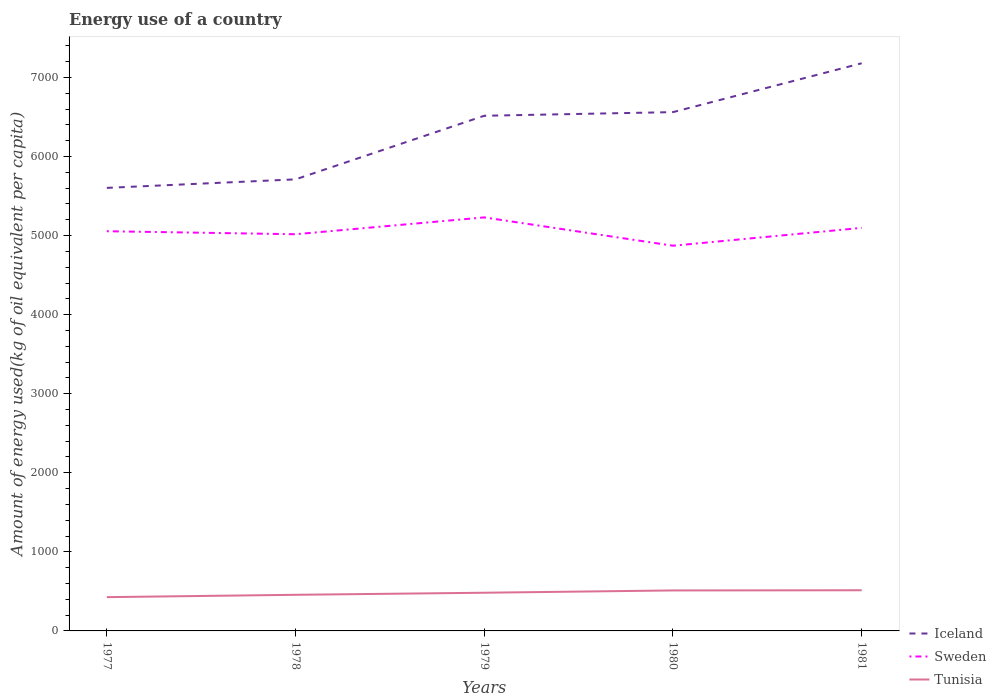Does the line corresponding to Iceland intersect with the line corresponding to Sweden?
Provide a succinct answer. No. Across all years, what is the maximum amount of energy used in in Sweden?
Your answer should be very brief. 4871.53. In which year was the amount of energy used in in Tunisia maximum?
Your response must be concise. 1977. What is the total amount of energy used in in Sweden in the graph?
Provide a short and direct response. 145.21. What is the difference between the highest and the second highest amount of energy used in in Iceland?
Your answer should be compact. 1576. Is the amount of energy used in in Tunisia strictly greater than the amount of energy used in in Sweden over the years?
Your response must be concise. Yes. How many years are there in the graph?
Your answer should be compact. 5. What is the difference between two consecutive major ticks on the Y-axis?
Offer a terse response. 1000. Are the values on the major ticks of Y-axis written in scientific E-notation?
Offer a terse response. No. Does the graph contain any zero values?
Make the answer very short. No. Does the graph contain grids?
Your answer should be compact. No. What is the title of the graph?
Offer a terse response. Energy use of a country. What is the label or title of the Y-axis?
Give a very brief answer. Amount of energy used(kg of oil equivalent per capita). What is the Amount of energy used(kg of oil equivalent per capita) in Iceland in 1977?
Offer a terse response. 5602.87. What is the Amount of energy used(kg of oil equivalent per capita) in Sweden in 1977?
Make the answer very short. 5054.83. What is the Amount of energy used(kg of oil equivalent per capita) in Tunisia in 1977?
Provide a succinct answer. 427.3. What is the Amount of energy used(kg of oil equivalent per capita) of Iceland in 1978?
Provide a succinct answer. 5710.71. What is the Amount of energy used(kg of oil equivalent per capita) in Sweden in 1978?
Your response must be concise. 5016.74. What is the Amount of energy used(kg of oil equivalent per capita) of Tunisia in 1978?
Provide a short and direct response. 456.79. What is the Amount of energy used(kg of oil equivalent per capita) of Iceland in 1979?
Offer a terse response. 6515.06. What is the Amount of energy used(kg of oil equivalent per capita) of Sweden in 1979?
Your response must be concise. 5229.62. What is the Amount of energy used(kg of oil equivalent per capita) of Tunisia in 1979?
Make the answer very short. 482.86. What is the Amount of energy used(kg of oil equivalent per capita) in Iceland in 1980?
Keep it short and to the point. 6561. What is the Amount of energy used(kg of oil equivalent per capita) of Sweden in 1980?
Offer a terse response. 4871.53. What is the Amount of energy used(kg of oil equivalent per capita) of Tunisia in 1980?
Your response must be concise. 511.9. What is the Amount of energy used(kg of oil equivalent per capita) of Iceland in 1981?
Offer a terse response. 7178.87. What is the Amount of energy used(kg of oil equivalent per capita) in Sweden in 1981?
Ensure brevity in your answer.  5097.15. What is the Amount of energy used(kg of oil equivalent per capita) of Tunisia in 1981?
Your response must be concise. 514.37. Across all years, what is the maximum Amount of energy used(kg of oil equivalent per capita) of Iceland?
Give a very brief answer. 7178.87. Across all years, what is the maximum Amount of energy used(kg of oil equivalent per capita) in Sweden?
Your answer should be compact. 5229.62. Across all years, what is the maximum Amount of energy used(kg of oil equivalent per capita) in Tunisia?
Make the answer very short. 514.37. Across all years, what is the minimum Amount of energy used(kg of oil equivalent per capita) of Iceland?
Offer a terse response. 5602.87. Across all years, what is the minimum Amount of energy used(kg of oil equivalent per capita) in Sweden?
Your answer should be very brief. 4871.53. Across all years, what is the minimum Amount of energy used(kg of oil equivalent per capita) in Tunisia?
Provide a succinct answer. 427.3. What is the total Amount of energy used(kg of oil equivalent per capita) of Iceland in the graph?
Provide a short and direct response. 3.16e+04. What is the total Amount of energy used(kg of oil equivalent per capita) in Sweden in the graph?
Give a very brief answer. 2.53e+04. What is the total Amount of energy used(kg of oil equivalent per capita) in Tunisia in the graph?
Your answer should be compact. 2393.22. What is the difference between the Amount of energy used(kg of oil equivalent per capita) of Iceland in 1977 and that in 1978?
Keep it short and to the point. -107.84. What is the difference between the Amount of energy used(kg of oil equivalent per capita) in Sweden in 1977 and that in 1978?
Your answer should be very brief. 38.09. What is the difference between the Amount of energy used(kg of oil equivalent per capita) in Tunisia in 1977 and that in 1978?
Provide a succinct answer. -29.49. What is the difference between the Amount of energy used(kg of oil equivalent per capita) in Iceland in 1977 and that in 1979?
Offer a very short reply. -912.19. What is the difference between the Amount of energy used(kg of oil equivalent per capita) of Sweden in 1977 and that in 1979?
Give a very brief answer. -174.78. What is the difference between the Amount of energy used(kg of oil equivalent per capita) of Tunisia in 1977 and that in 1979?
Ensure brevity in your answer.  -55.56. What is the difference between the Amount of energy used(kg of oil equivalent per capita) in Iceland in 1977 and that in 1980?
Your answer should be compact. -958.13. What is the difference between the Amount of energy used(kg of oil equivalent per capita) of Sweden in 1977 and that in 1980?
Your response must be concise. 183.3. What is the difference between the Amount of energy used(kg of oil equivalent per capita) of Tunisia in 1977 and that in 1980?
Provide a short and direct response. -84.59. What is the difference between the Amount of energy used(kg of oil equivalent per capita) of Iceland in 1977 and that in 1981?
Give a very brief answer. -1576. What is the difference between the Amount of energy used(kg of oil equivalent per capita) of Sweden in 1977 and that in 1981?
Ensure brevity in your answer.  -42.32. What is the difference between the Amount of energy used(kg of oil equivalent per capita) in Tunisia in 1977 and that in 1981?
Provide a succinct answer. -87.07. What is the difference between the Amount of energy used(kg of oil equivalent per capita) in Iceland in 1978 and that in 1979?
Your answer should be compact. -804.35. What is the difference between the Amount of energy used(kg of oil equivalent per capita) of Sweden in 1978 and that in 1979?
Offer a very short reply. -212.88. What is the difference between the Amount of energy used(kg of oil equivalent per capita) in Tunisia in 1978 and that in 1979?
Your answer should be compact. -26.07. What is the difference between the Amount of energy used(kg of oil equivalent per capita) in Iceland in 1978 and that in 1980?
Ensure brevity in your answer.  -850.29. What is the difference between the Amount of energy used(kg of oil equivalent per capita) of Sweden in 1978 and that in 1980?
Your answer should be very brief. 145.21. What is the difference between the Amount of energy used(kg of oil equivalent per capita) of Tunisia in 1978 and that in 1980?
Offer a very short reply. -55.1. What is the difference between the Amount of energy used(kg of oil equivalent per capita) in Iceland in 1978 and that in 1981?
Provide a short and direct response. -1468.16. What is the difference between the Amount of energy used(kg of oil equivalent per capita) in Sweden in 1978 and that in 1981?
Offer a terse response. -80.41. What is the difference between the Amount of energy used(kg of oil equivalent per capita) in Tunisia in 1978 and that in 1981?
Offer a very short reply. -57.58. What is the difference between the Amount of energy used(kg of oil equivalent per capita) of Iceland in 1979 and that in 1980?
Offer a terse response. -45.94. What is the difference between the Amount of energy used(kg of oil equivalent per capita) of Sweden in 1979 and that in 1980?
Your response must be concise. 358.08. What is the difference between the Amount of energy used(kg of oil equivalent per capita) of Tunisia in 1979 and that in 1980?
Make the answer very short. -29.03. What is the difference between the Amount of energy used(kg of oil equivalent per capita) in Iceland in 1979 and that in 1981?
Offer a terse response. -663.81. What is the difference between the Amount of energy used(kg of oil equivalent per capita) in Sweden in 1979 and that in 1981?
Give a very brief answer. 132.46. What is the difference between the Amount of energy used(kg of oil equivalent per capita) in Tunisia in 1979 and that in 1981?
Make the answer very short. -31.51. What is the difference between the Amount of energy used(kg of oil equivalent per capita) of Iceland in 1980 and that in 1981?
Your answer should be very brief. -617.87. What is the difference between the Amount of energy used(kg of oil equivalent per capita) of Sweden in 1980 and that in 1981?
Provide a short and direct response. -225.62. What is the difference between the Amount of energy used(kg of oil equivalent per capita) in Tunisia in 1980 and that in 1981?
Your response must be concise. -2.47. What is the difference between the Amount of energy used(kg of oil equivalent per capita) of Iceland in 1977 and the Amount of energy used(kg of oil equivalent per capita) of Sweden in 1978?
Your response must be concise. 586.13. What is the difference between the Amount of energy used(kg of oil equivalent per capita) of Iceland in 1977 and the Amount of energy used(kg of oil equivalent per capita) of Tunisia in 1978?
Give a very brief answer. 5146.08. What is the difference between the Amount of energy used(kg of oil equivalent per capita) of Sweden in 1977 and the Amount of energy used(kg of oil equivalent per capita) of Tunisia in 1978?
Keep it short and to the point. 4598.04. What is the difference between the Amount of energy used(kg of oil equivalent per capita) of Iceland in 1977 and the Amount of energy used(kg of oil equivalent per capita) of Sweden in 1979?
Provide a succinct answer. 373.25. What is the difference between the Amount of energy used(kg of oil equivalent per capita) in Iceland in 1977 and the Amount of energy used(kg of oil equivalent per capita) in Tunisia in 1979?
Give a very brief answer. 5120.01. What is the difference between the Amount of energy used(kg of oil equivalent per capita) of Sweden in 1977 and the Amount of energy used(kg of oil equivalent per capita) of Tunisia in 1979?
Your response must be concise. 4571.97. What is the difference between the Amount of energy used(kg of oil equivalent per capita) of Iceland in 1977 and the Amount of energy used(kg of oil equivalent per capita) of Sweden in 1980?
Provide a short and direct response. 731.34. What is the difference between the Amount of energy used(kg of oil equivalent per capita) in Iceland in 1977 and the Amount of energy used(kg of oil equivalent per capita) in Tunisia in 1980?
Ensure brevity in your answer.  5090.98. What is the difference between the Amount of energy used(kg of oil equivalent per capita) of Sweden in 1977 and the Amount of energy used(kg of oil equivalent per capita) of Tunisia in 1980?
Provide a succinct answer. 4542.94. What is the difference between the Amount of energy used(kg of oil equivalent per capita) of Iceland in 1977 and the Amount of energy used(kg of oil equivalent per capita) of Sweden in 1981?
Make the answer very short. 505.72. What is the difference between the Amount of energy used(kg of oil equivalent per capita) in Iceland in 1977 and the Amount of energy used(kg of oil equivalent per capita) in Tunisia in 1981?
Offer a terse response. 5088.5. What is the difference between the Amount of energy used(kg of oil equivalent per capita) of Sweden in 1977 and the Amount of energy used(kg of oil equivalent per capita) of Tunisia in 1981?
Your answer should be compact. 4540.47. What is the difference between the Amount of energy used(kg of oil equivalent per capita) of Iceland in 1978 and the Amount of energy used(kg of oil equivalent per capita) of Sweden in 1979?
Provide a succinct answer. 481.09. What is the difference between the Amount of energy used(kg of oil equivalent per capita) in Iceland in 1978 and the Amount of energy used(kg of oil equivalent per capita) in Tunisia in 1979?
Your answer should be compact. 5227.85. What is the difference between the Amount of energy used(kg of oil equivalent per capita) of Sweden in 1978 and the Amount of energy used(kg of oil equivalent per capita) of Tunisia in 1979?
Provide a short and direct response. 4533.88. What is the difference between the Amount of energy used(kg of oil equivalent per capita) in Iceland in 1978 and the Amount of energy used(kg of oil equivalent per capita) in Sweden in 1980?
Provide a succinct answer. 839.18. What is the difference between the Amount of energy used(kg of oil equivalent per capita) in Iceland in 1978 and the Amount of energy used(kg of oil equivalent per capita) in Tunisia in 1980?
Offer a very short reply. 5198.81. What is the difference between the Amount of energy used(kg of oil equivalent per capita) of Sweden in 1978 and the Amount of energy used(kg of oil equivalent per capita) of Tunisia in 1980?
Give a very brief answer. 4504.85. What is the difference between the Amount of energy used(kg of oil equivalent per capita) in Iceland in 1978 and the Amount of energy used(kg of oil equivalent per capita) in Sweden in 1981?
Your answer should be very brief. 613.56. What is the difference between the Amount of energy used(kg of oil equivalent per capita) in Iceland in 1978 and the Amount of energy used(kg of oil equivalent per capita) in Tunisia in 1981?
Your answer should be very brief. 5196.34. What is the difference between the Amount of energy used(kg of oil equivalent per capita) in Sweden in 1978 and the Amount of energy used(kg of oil equivalent per capita) in Tunisia in 1981?
Provide a succinct answer. 4502.37. What is the difference between the Amount of energy used(kg of oil equivalent per capita) of Iceland in 1979 and the Amount of energy used(kg of oil equivalent per capita) of Sweden in 1980?
Give a very brief answer. 1643.53. What is the difference between the Amount of energy used(kg of oil equivalent per capita) in Iceland in 1979 and the Amount of energy used(kg of oil equivalent per capita) in Tunisia in 1980?
Ensure brevity in your answer.  6003.16. What is the difference between the Amount of energy used(kg of oil equivalent per capita) in Sweden in 1979 and the Amount of energy used(kg of oil equivalent per capita) in Tunisia in 1980?
Provide a succinct answer. 4717.72. What is the difference between the Amount of energy used(kg of oil equivalent per capita) of Iceland in 1979 and the Amount of energy used(kg of oil equivalent per capita) of Sweden in 1981?
Your response must be concise. 1417.91. What is the difference between the Amount of energy used(kg of oil equivalent per capita) in Iceland in 1979 and the Amount of energy used(kg of oil equivalent per capita) in Tunisia in 1981?
Make the answer very short. 6000.69. What is the difference between the Amount of energy used(kg of oil equivalent per capita) of Sweden in 1979 and the Amount of energy used(kg of oil equivalent per capita) of Tunisia in 1981?
Offer a terse response. 4715.25. What is the difference between the Amount of energy used(kg of oil equivalent per capita) of Iceland in 1980 and the Amount of energy used(kg of oil equivalent per capita) of Sweden in 1981?
Your answer should be very brief. 1463.84. What is the difference between the Amount of energy used(kg of oil equivalent per capita) in Iceland in 1980 and the Amount of energy used(kg of oil equivalent per capita) in Tunisia in 1981?
Your answer should be compact. 6046.63. What is the difference between the Amount of energy used(kg of oil equivalent per capita) of Sweden in 1980 and the Amount of energy used(kg of oil equivalent per capita) of Tunisia in 1981?
Provide a succinct answer. 4357.16. What is the average Amount of energy used(kg of oil equivalent per capita) in Iceland per year?
Your answer should be very brief. 6313.7. What is the average Amount of energy used(kg of oil equivalent per capita) of Sweden per year?
Ensure brevity in your answer.  5053.98. What is the average Amount of energy used(kg of oil equivalent per capita) of Tunisia per year?
Provide a succinct answer. 478.64. In the year 1977, what is the difference between the Amount of energy used(kg of oil equivalent per capita) in Iceland and Amount of energy used(kg of oil equivalent per capita) in Sweden?
Offer a terse response. 548.04. In the year 1977, what is the difference between the Amount of energy used(kg of oil equivalent per capita) of Iceland and Amount of energy used(kg of oil equivalent per capita) of Tunisia?
Your answer should be compact. 5175.57. In the year 1977, what is the difference between the Amount of energy used(kg of oil equivalent per capita) of Sweden and Amount of energy used(kg of oil equivalent per capita) of Tunisia?
Your response must be concise. 4627.53. In the year 1978, what is the difference between the Amount of energy used(kg of oil equivalent per capita) of Iceland and Amount of energy used(kg of oil equivalent per capita) of Sweden?
Ensure brevity in your answer.  693.97. In the year 1978, what is the difference between the Amount of energy used(kg of oil equivalent per capita) in Iceland and Amount of energy used(kg of oil equivalent per capita) in Tunisia?
Your answer should be compact. 5253.92. In the year 1978, what is the difference between the Amount of energy used(kg of oil equivalent per capita) of Sweden and Amount of energy used(kg of oil equivalent per capita) of Tunisia?
Provide a succinct answer. 4559.95. In the year 1979, what is the difference between the Amount of energy used(kg of oil equivalent per capita) of Iceland and Amount of energy used(kg of oil equivalent per capita) of Sweden?
Offer a very short reply. 1285.44. In the year 1979, what is the difference between the Amount of energy used(kg of oil equivalent per capita) in Iceland and Amount of energy used(kg of oil equivalent per capita) in Tunisia?
Keep it short and to the point. 6032.2. In the year 1979, what is the difference between the Amount of energy used(kg of oil equivalent per capita) in Sweden and Amount of energy used(kg of oil equivalent per capita) in Tunisia?
Offer a terse response. 4746.76. In the year 1980, what is the difference between the Amount of energy used(kg of oil equivalent per capita) of Iceland and Amount of energy used(kg of oil equivalent per capita) of Sweden?
Provide a succinct answer. 1689.46. In the year 1980, what is the difference between the Amount of energy used(kg of oil equivalent per capita) of Iceland and Amount of energy used(kg of oil equivalent per capita) of Tunisia?
Ensure brevity in your answer.  6049.1. In the year 1980, what is the difference between the Amount of energy used(kg of oil equivalent per capita) of Sweden and Amount of energy used(kg of oil equivalent per capita) of Tunisia?
Ensure brevity in your answer.  4359.64. In the year 1981, what is the difference between the Amount of energy used(kg of oil equivalent per capita) in Iceland and Amount of energy used(kg of oil equivalent per capita) in Sweden?
Your answer should be very brief. 2081.71. In the year 1981, what is the difference between the Amount of energy used(kg of oil equivalent per capita) in Iceland and Amount of energy used(kg of oil equivalent per capita) in Tunisia?
Your response must be concise. 6664.5. In the year 1981, what is the difference between the Amount of energy used(kg of oil equivalent per capita) of Sweden and Amount of energy used(kg of oil equivalent per capita) of Tunisia?
Your answer should be very brief. 4582.79. What is the ratio of the Amount of energy used(kg of oil equivalent per capita) in Iceland in 1977 to that in 1978?
Give a very brief answer. 0.98. What is the ratio of the Amount of energy used(kg of oil equivalent per capita) of Sweden in 1977 to that in 1978?
Your answer should be very brief. 1.01. What is the ratio of the Amount of energy used(kg of oil equivalent per capita) in Tunisia in 1977 to that in 1978?
Provide a short and direct response. 0.94. What is the ratio of the Amount of energy used(kg of oil equivalent per capita) in Iceland in 1977 to that in 1979?
Provide a short and direct response. 0.86. What is the ratio of the Amount of energy used(kg of oil equivalent per capita) in Sweden in 1977 to that in 1979?
Offer a very short reply. 0.97. What is the ratio of the Amount of energy used(kg of oil equivalent per capita) of Tunisia in 1977 to that in 1979?
Provide a short and direct response. 0.88. What is the ratio of the Amount of energy used(kg of oil equivalent per capita) of Iceland in 1977 to that in 1980?
Your answer should be very brief. 0.85. What is the ratio of the Amount of energy used(kg of oil equivalent per capita) in Sweden in 1977 to that in 1980?
Give a very brief answer. 1.04. What is the ratio of the Amount of energy used(kg of oil equivalent per capita) of Tunisia in 1977 to that in 1980?
Provide a succinct answer. 0.83. What is the ratio of the Amount of energy used(kg of oil equivalent per capita) of Iceland in 1977 to that in 1981?
Offer a terse response. 0.78. What is the ratio of the Amount of energy used(kg of oil equivalent per capita) of Tunisia in 1977 to that in 1981?
Offer a very short reply. 0.83. What is the ratio of the Amount of energy used(kg of oil equivalent per capita) of Iceland in 1978 to that in 1979?
Make the answer very short. 0.88. What is the ratio of the Amount of energy used(kg of oil equivalent per capita) of Sweden in 1978 to that in 1979?
Ensure brevity in your answer.  0.96. What is the ratio of the Amount of energy used(kg of oil equivalent per capita) of Tunisia in 1978 to that in 1979?
Ensure brevity in your answer.  0.95. What is the ratio of the Amount of energy used(kg of oil equivalent per capita) in Iceland in 1978 to that in 1980?
Offer a terse response. 0.87. What is the ratio of the Amount of energy used(kg of oil equivalent per capita) of Sweden in 1978 to that in 1980?
Ensure brevity in your answer.  1.03. What is the ratio of the Amount of energy used(kg of oil equivalent per capita) in Tunisia in 1978 to that in 1980?
Your response must be concise. 0.89. What is the ratio of the Amount of energy used(kg of oil equivalent per capita) of Iceland in 1978 to that in 1981?
Make the answer very short. 0.8. What is the ratio of the Amount of energy used(kg of oil equivalent per capita) of Sweden in 1978 to that in 1981?
Your answer should be compact. 0.98. What is the ratio of the Amount of energy used(kg of oil equivalent per capita) in Tunisia in 1978 to that in 1981?
Keep it short and to the point. 0.89. What is the ratio of the Amount of energy used(kg of oil equivalent per capita) in Sweden in 1979 to that in 1980?
Your answer should be very brief. 1.07. What is the ratio of the Amount of energy used(kg of oil equivalent per capita) of Tunisia in 1979 to that in 1980?
Make the answer very short. 0.94. What is the ratio of the Amount of energy used(kg of oil equivalent per capita) in Iceland in 1979 to that in 1981?
Your answer should be very brief. 0.91. What is the ratio of the Amount of energy used(kg of oil equivalent per capita) in Sweden in 1979 to that in 1981?
Give a very brief answer. 1.03. What is the ratio of the Amount of energy used(kg of oil equivalent per capita) of Tunisia in 1979 to that in 1981?
Provide a succinct answer. 0.94. What is the ratio of the Amount of energy used(kg of oil equivalent per capita) of Iceland in 1980 to that in 1981?
Offer a terse response. 0.91. What is the ratio of the Amount of energy used(kg of oil equivalent per capita) of Sweden in 1980 to that in 1981?
Ensure brevity in your answer.  0.96. What is the ratio of the Amount of energy used(kg of oil equivalent per capita) in Tunisia in 1980 to that in 1981?
Offer a very short reply. 1. What is the difference between the highest and the second highest Amount of energy used(kg of oil equivalent per capita) of Iceland?
Ensure brevity in your answer.  617.87. What is the difference between the highest and the second highest Amount of energy used(kg of oil equivalent per capita) of Sweden?
Your answer should be compact. 132.46. What is the difference between the highest and the second highest Amount of energy used(kg of oil equivalent per capita) in Tunisia?
Your answer should be compact. 2.47. What is the difference between the highest and the lowest Amount of energy used(kg of oil equivalent per capita) of Iceland?
Offer a very short reply. 1576. What is the difference between the highest and the lowest Amount of energy used(kg of oil equivalent per capita) in Sweden?
Your response must be concise. 358.08. What is the difference between the highest and the lowest Amount of energy used(kg of oil equivalent per capita) in Tunisia?
Keep it short and to the point. 87.07. 